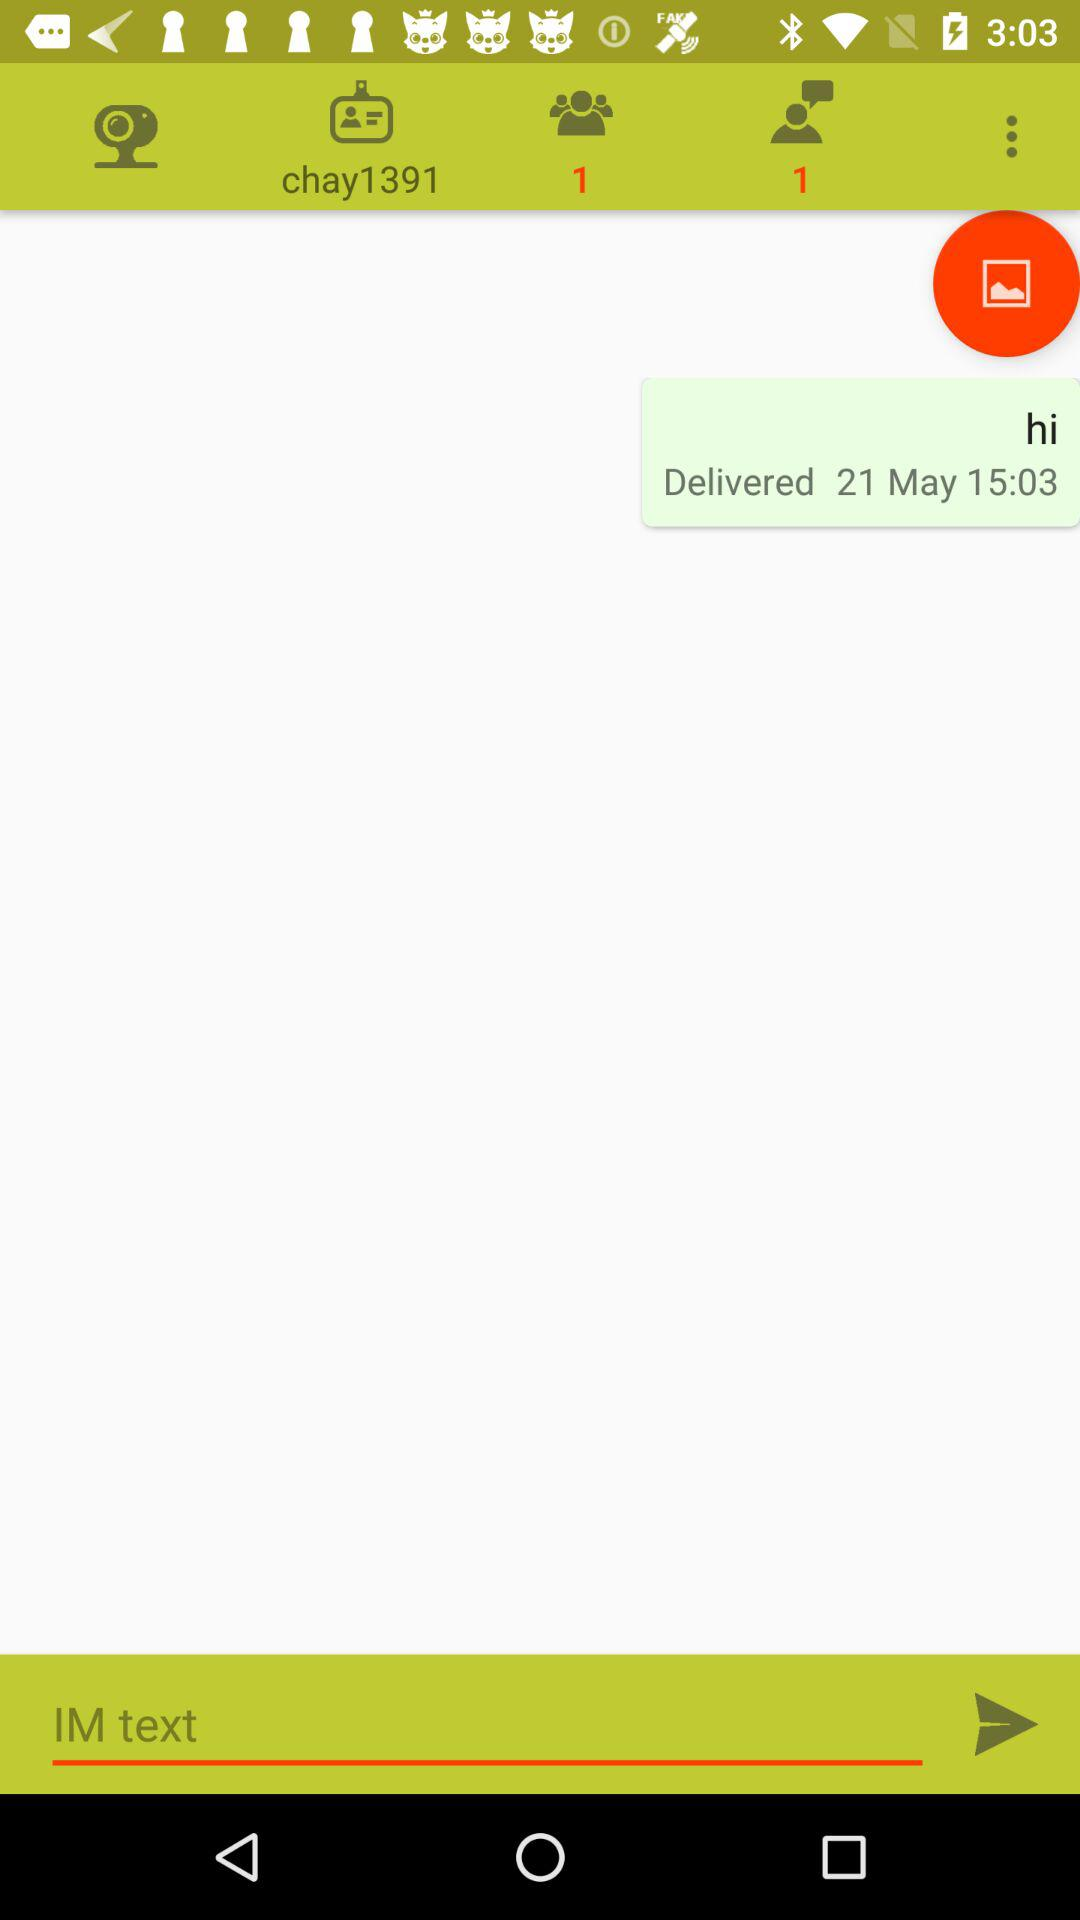How many messages are unread? There is 1 unread message. 